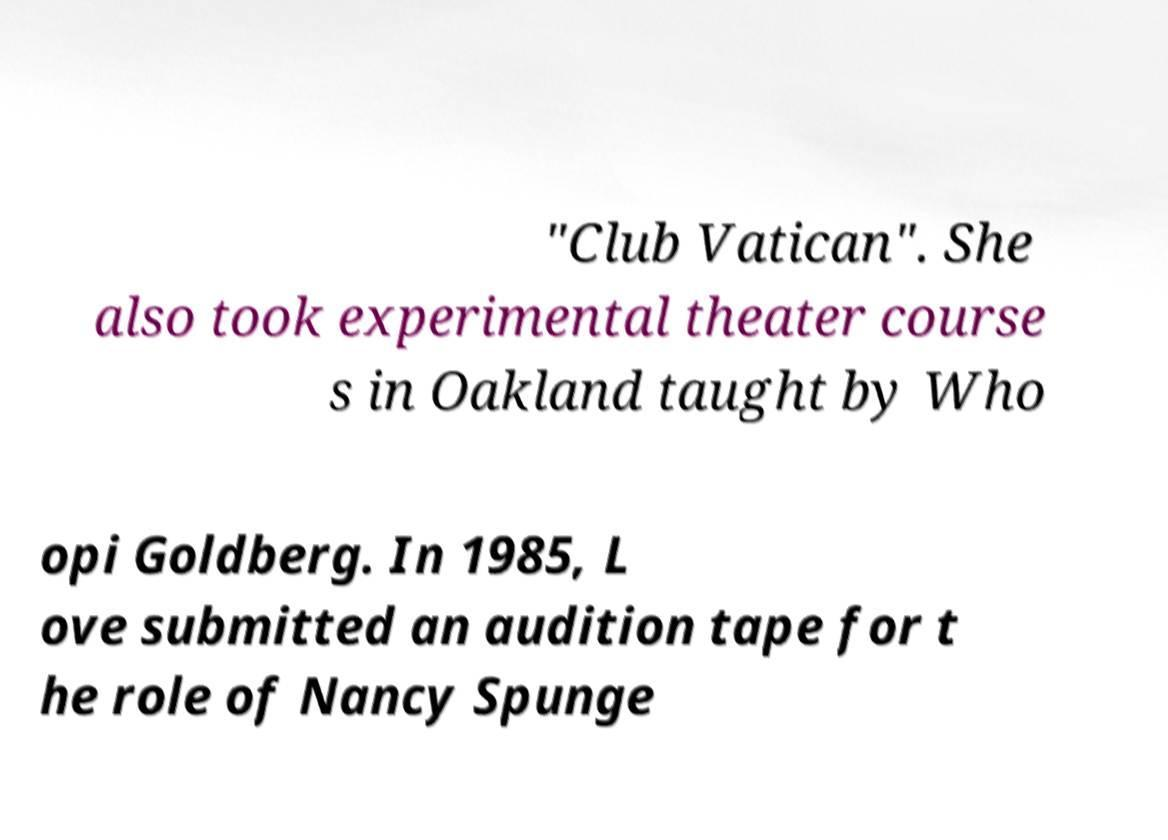Please identify and transcribe the text found in this image. "Club Vatican". She also took experimental theater course s in Oakland taught by Who opi Goldberg. In 1985, L ove submitted an audition tape for t he role of Nancy Spunge 